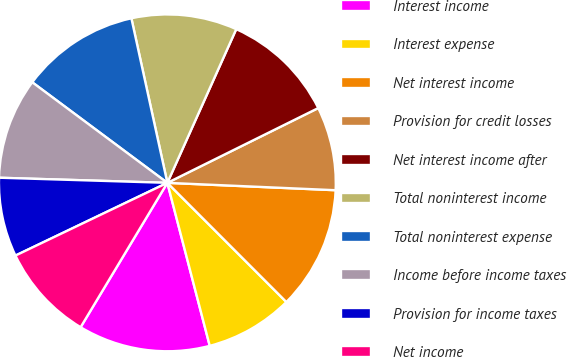Convert chart to OTSL. <chart><loc_0><loc_0><loc_500><loc_500><pie_chart><fcel>Interest income<fcel>Interest expense<fcel>Net interest income<fcel>Provision for credit losses<fcel>Net interest income after<fcel>Total noninterest income<fcel>Total noninterest expense<fcel>Income before income taxes<fcel>Provision for income taxes<fcel>Net income<nl><fcel>12.66%<fcel>8.44%<fcel>11.81%<fcel>8.02%<fcel>10.97%<fcel>10.13%<fcel>11.39%<fcel>9.7%<fcel>7.59%<fcel>9.28%<nl></chart> 